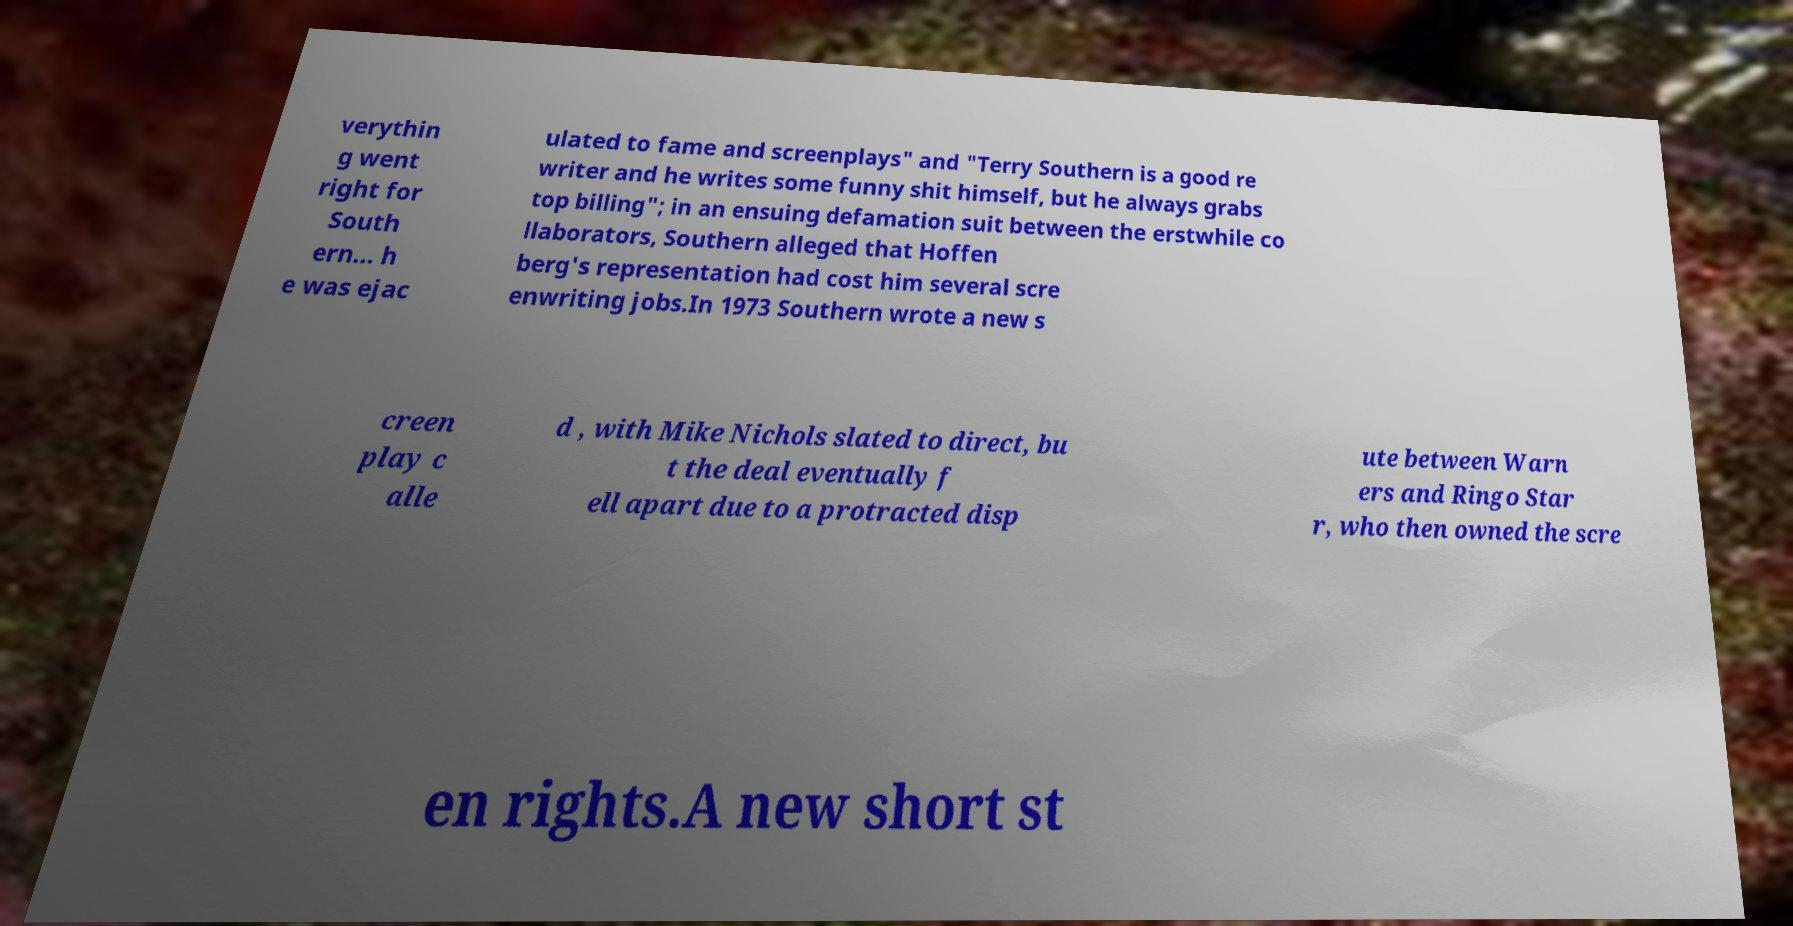What messages or text are displayed in this image? I need them in a readable, typed format. verythin g went right for South ern... h e was ejac ulated to fame and screenplays" and "Terry Southern is a good re writer and he writes some funny shit himself, but he always grabs top billing"; in an ensuing defamation suit between the erstwhile co llaborators, Southern alleged that Hoffen berg's representation had cost him several scre enwriting jobs.In 1973 Southern wrote a new s creen play c alle d , with Mike Nichols slated to direct, bu t the deal eventually f ell apart due to a protracted disp ute between Warn ers and Ringo Star r, who then owned the scre en rights.A new short st 